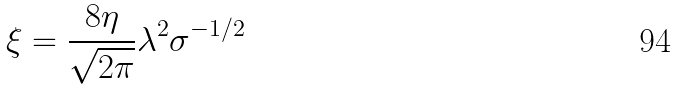<formula> <loc_0><loc_0><loc_500><loc_500>\xi = \frac { 8 \eta } { \sqrt { 2 \pi } } \lambda ^ { 2 } \sigma ^ { - 1 / 2 }</formula> 